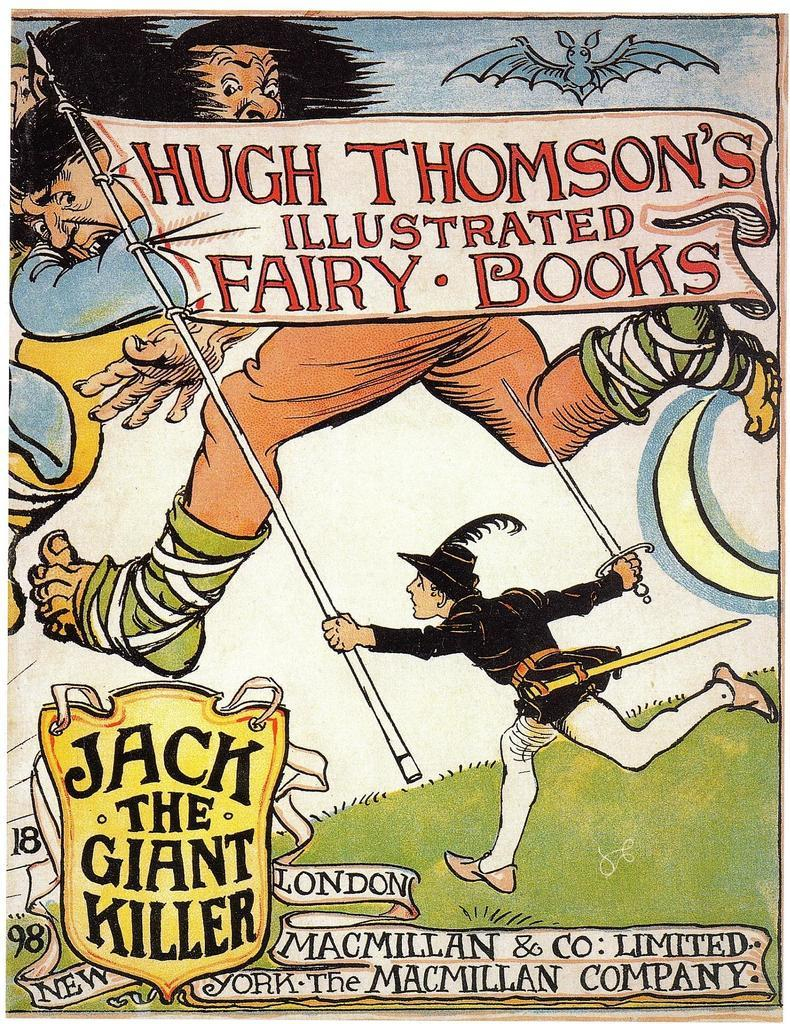<image>
Relay a brief, clear account of the picture shown. Poster for Jack The Giant Killer showing a man holding a flag. 